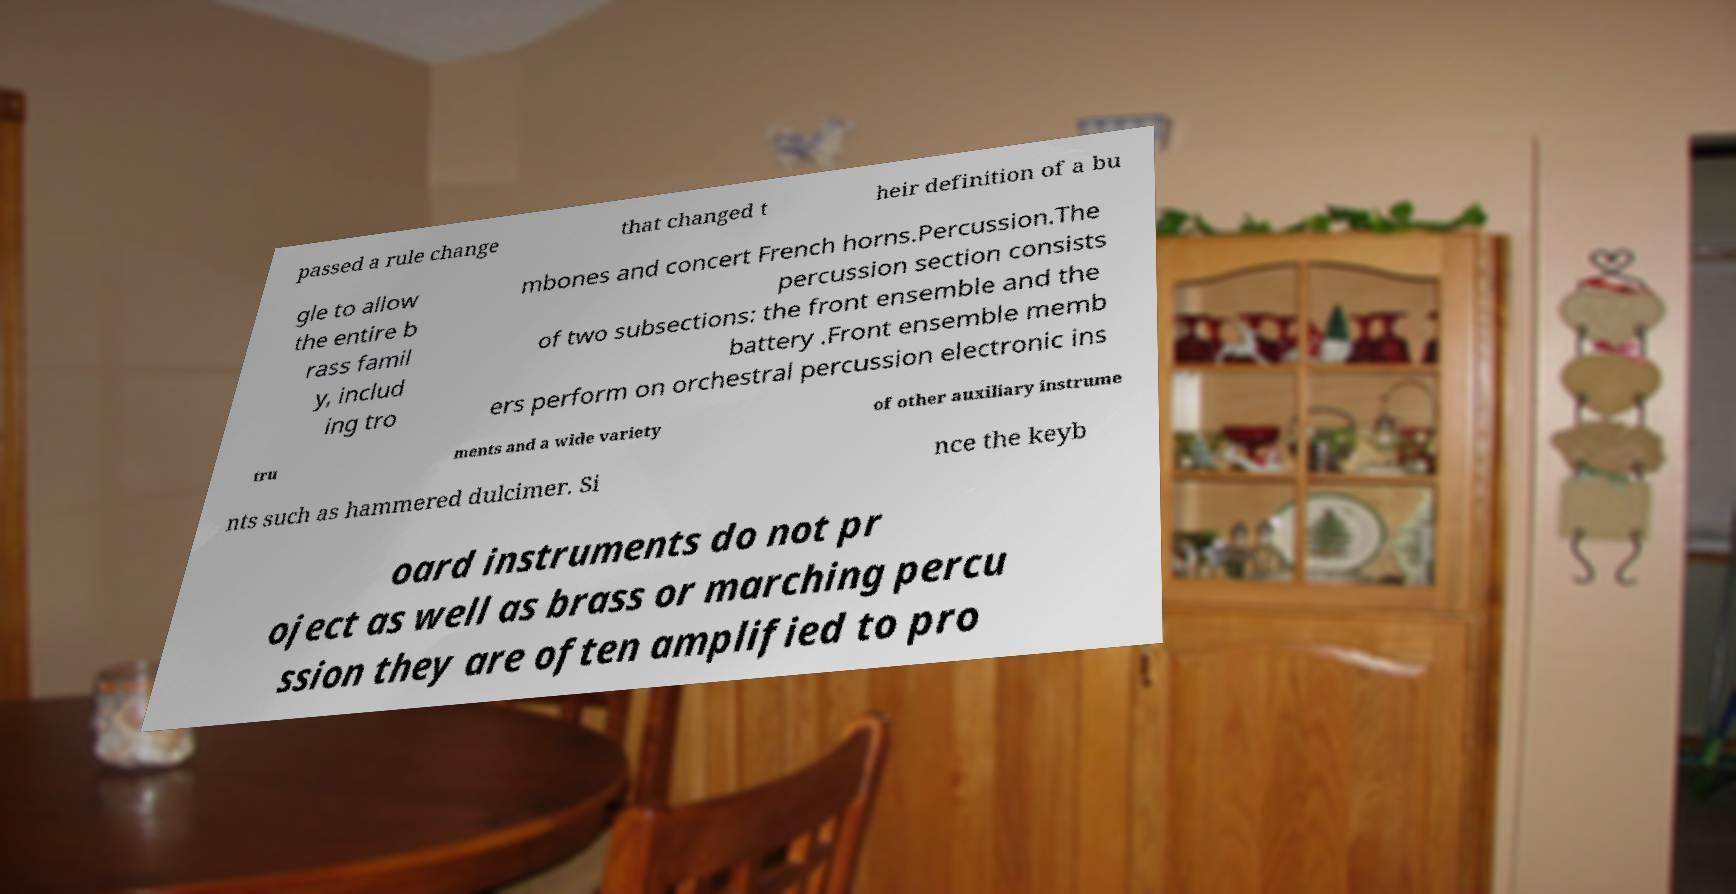Can you read and provide the text displayed in the image?This photo seems to have some interesting text. Can you extract and type it out for me? passed a rule change that changed t heir definition of a bu gle to allow the entire b rass famil y, includ ing tro mbones and concert French horns.Percussion.The percussion section consists of two subsections: the front ensemble and the battery .Front ensemble memb ers perform on orchestral percussion electronic ins tru ments and a wide variety of other auxiliary instrume nts such as hammered dulcimer. Si nce the keyb oard instruments do not pr oject as well as brass or marching percu ssion they are often amplified to pro 